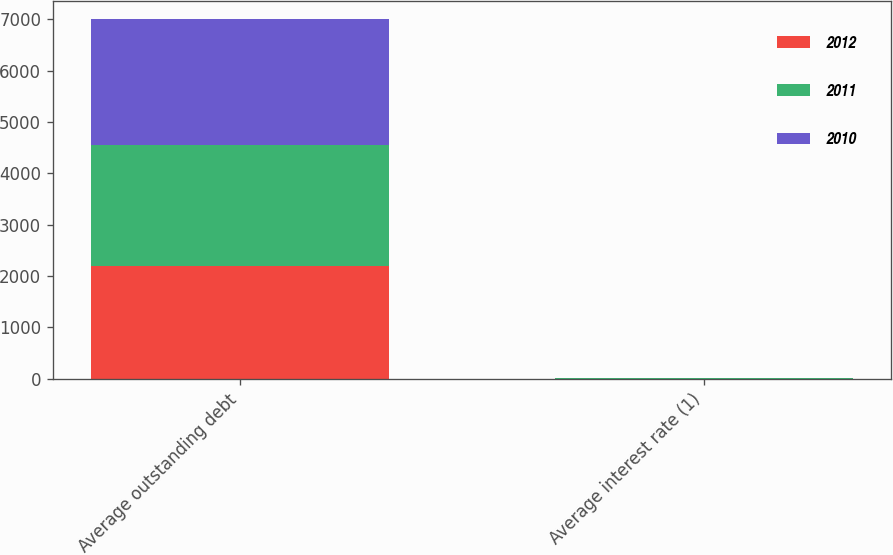Convert chart. <chart><loc_0><loc_0><loc_500><loc_500><stacked_bar_chart><ecel><fcel>Average outstanding debt<fcel>Average interest rate (1)<nl><fcel>2012<fcel>2195.5<fcel>3.5<nl><fcel>2011<fcel>2351.3<fcel>3.6<nl><fcel>2010<fcel>2461<fcel>4.8<nl></chart> 